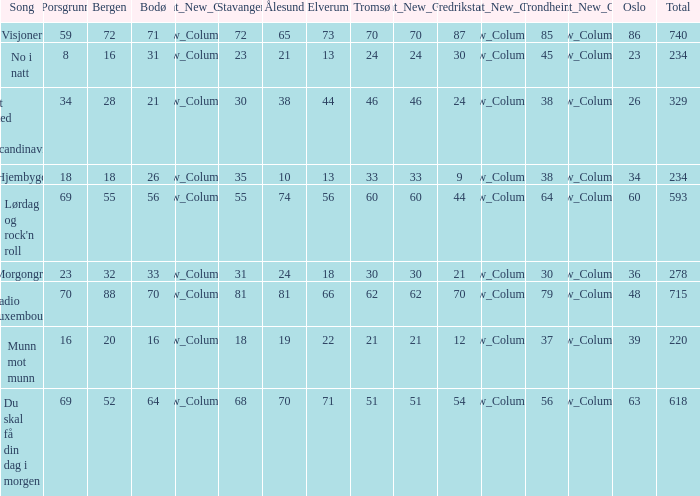What is the minimum sum? 220.0. 